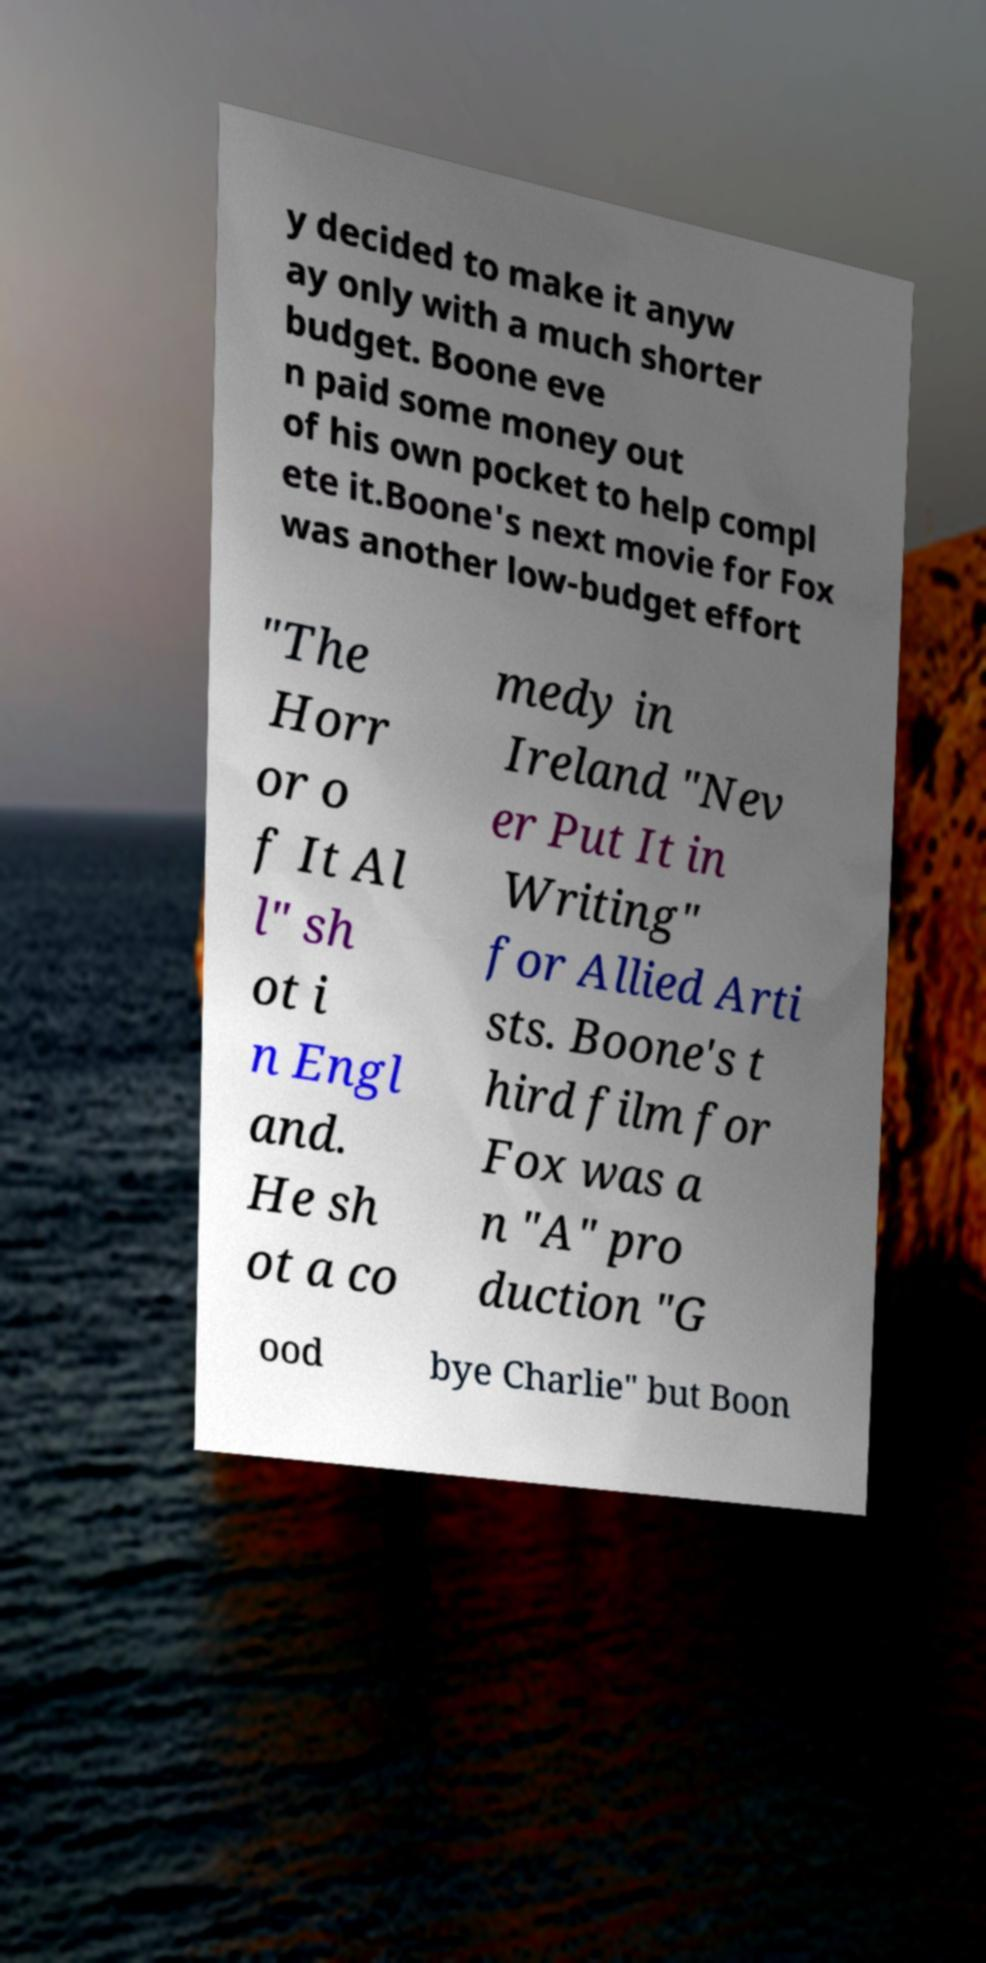Can you accurately transcribe the text from the provided image for me? y decided to make it anyw ay only with a much shorter budget. Boone eve n paid some money out of his own pocket to help compl ete it.Boone's next movie for Fox was another low-budget effort "The Horr or o f It Al l" sh ot i n Engl and. He sh ot a co medy in Ireland "Nev er Put It in Writing" for Allied Arti sts. Boone's t hird film for Fox was a n "A" pro duction "G ood bye Charlie" but Boon 